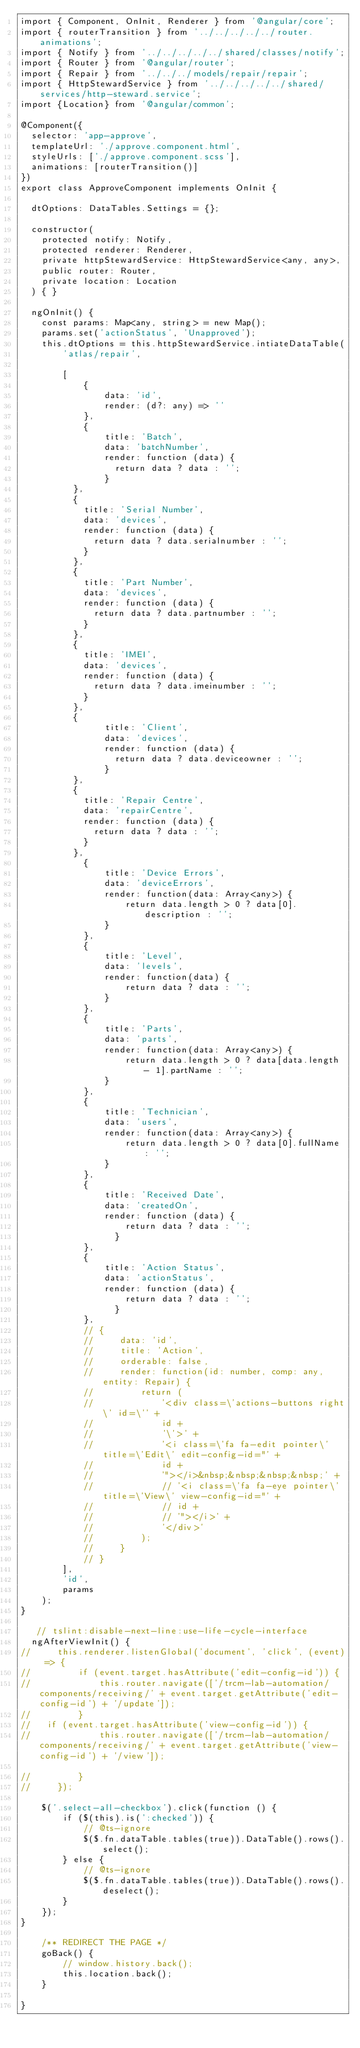Convert code to text. <code><loc_0><loc_0><loc_500><loc_500><_TypeScript_>import { Component, OnInit, Renderer } from '@angular/core';
import { routerTransition } from '../../../../../router.animations';
import { Notify } from '../../../../../shared/classes/notify';
import { Router } from '@angular/router';
import { Repair } from '../../../models/repair/repair';
import { HttpStewardService } from '../../../../../shared/services/http-steward.service';
import {Location} from '@angular/common';

@Component({
  selector: 'app-approve',
  templateUrl: './approve.component.html',
  styleUrls: ['./approve.component.scss'],
  animations: [routerTransition()]
})
export class ApproveComponent implements OnInit {

  dtOptions: DataTables.Settings = {};

  constructor(
    protected notify: Notify,
    protected renderer: Renderer,
    private httpStewardService: HttpStewardService<any, any>,
    public router: Router,
    private location: Location
  ) { }

  ngOnInit() {
    const params: Map<any, string> = new Map();
    params.set('actionStatus', 'Unapproved');
    this.dtOptions = this.httpStewardService.intiateDataTable(
        'atlas/repair',

        [
            {
                data: 'id',
                render: (d?: any) => ''
            },
            {
                title: 'Batch',
                data: 'batchNumber',
                render: function (data) {
                  return data ? data : '';
                }
          },
          {
            title: 'Serial Number',
            data: 'devices',
            render: function (data) {
              return data ? data.serialnumber : '';
            }
          },
          {
            title: 'Part Number',
            data: 'devices',
            render: function (data) {
              return data ? data.partnumber : '';
            }
          },
          {
            title: 'IMEI',
            data: 'devices',
            render: function (data) {
              return data ? data.imeinumber : '';
            }
          },
          {
                title: 'Client',
                data: 'devices',
                render: function (data) {
                  return data ? data.deviceowner : '';
                }
          },
          {
            title: 'Repair Centre',
            data: 'repairCentre',
            render: function (data) {
              return data ? data : '';
            }
          },
            {
                title: 'Device Errors',
                data: 'deviceErrors',
                render: function(data: Array<any>) {
                    return data.length > 0 ? data[0].description : '';
                }
            },
            {
                title: 'Level',
                data: 'levels',
                render: function(data) {
                    return data ? data : '';
                }
            },
            {
                title: 'Parts',
                data: 'parts',
                render: function(data: Array<any>) {
                    return data.length > 0 ? data[data.length - 1].partName : '';
                }
            },
            {
                title: 'Technician',
                data: 'users',
                render: function(data: Array<any>) {
                    return data.length > 0 ? data[0].fullName : '';
                }
            },
            {
                title: 'Received Date',
                data: 'createdOn',
                render: function (data) {
                    return data ? data : '';
                  }
            },
            {
                title: 'Action Status',
                data: 'actionStatus',
                render: function (data) {
                    return data ? data : '';
                  }
            },
            // {
            //     data: 'id',
            //     title: 'Action',
            //     orderable: false,
            //     render: function(id: number, comp: any, entity: Repair) {
            //         return (
            //             '<div class=\'actions-buttons right\' id=\'' +
            //             id +
            //             '\'>' +
            //             '<i class=\'fa fa-edit pointer\' title=\'Edit\' edit-config-id="' +
            //             id +
            //             '"></i>&nbsp;&nbsp;&nbsp;&nbsp;' +
            //             // '<i class=\'fa fa-eye pointer\' title=\'View\' view-config-id="' +
            //             // id +
            //             // '"></i>' +
            //             '</div>'
            //         );
            //     }
            // }
        ],
        'id',
        params
    );
}

   // tslint:disable-next-line:use-life-cycle-interface
  ngAfterViewInit() {
//     this.renderer.listenGlobal('document', 'click', (event) => {
//         if (event.target.hasAttribute('edit-config-id')) {
//             this.router.navigate(['/trcm-lab-automation/components/receiving/' + event.target.getAttribute('edit-config-id') + '/update']);
//         }
//   if (event.target.hasAttribute('view-config-id')) {
//             this.router.navigate(['/trcm-lab-automation/components/receiving/' + event.target.getAttribute('view-config-id') + '/view']);

//         }
//     });

    $('.select-all-checkbox').click(function () {
        if ($(this).is(':checked')) {
            // @ts-ignore
            $($.fn.dataTable.tables(true)).DataTable().rows().select();
        } else {
            // @ts-ignore
            $($.fn.dataTable.tables(true)).DataTable().rows().deselect();
        }
    });
}

    /** REDIRECT THE PAGE */
    goBack() {
        // window.history.back();
        this.location.back();
    }

}
</code> 